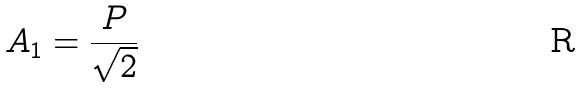Convert formula to latex. <formula><loc_0><loc_0><loc_500><loc_500>A _ { 1 } = \frac { P } { \sqrt { 2 } }</formula> 